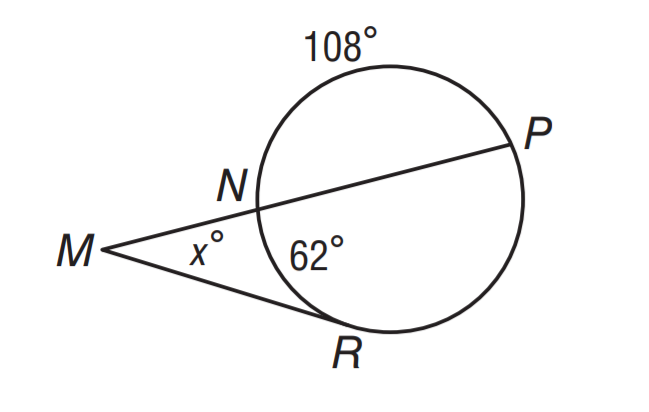Question: What is the value of x if m \widehat N R = 62 and m \widehat N P = 108?
Choices:
A. 23
B. 31
C. 64
D. 128
Answer with the letter. Answer: C 